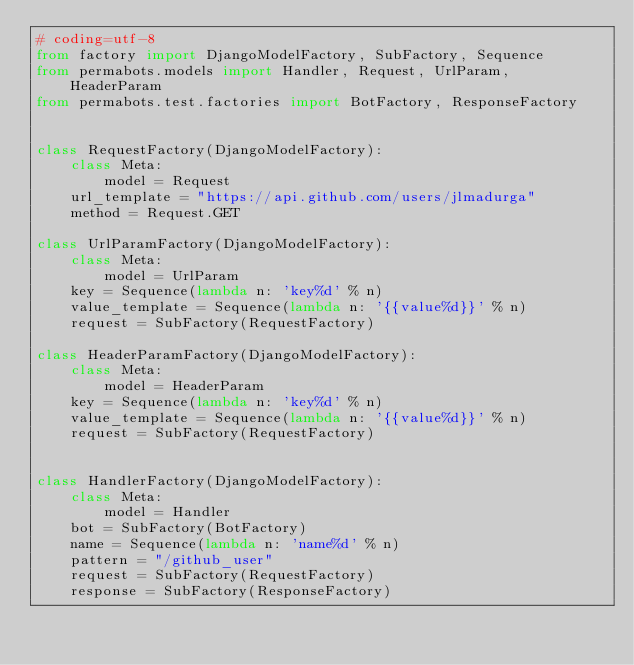<code> <loc_0><loc_0><loc_500><loc_500><_Python_># coding=utf-8
from factory import DjangoModelFactory, SubFactory, Sequence
from permabots.models import Handler, Request, UrlParam, HeaderParam
from permabots.test.factories import BotFactory, ResponseFactory


class RequestFactory(DjangoModelFactory):
    class Meta:
        model = Request
    url_template = "https://api.github.com/users/jlmadurga"
    method = Request.GET
    
class UrlParamFactory(DjangoModelFactory):
    class Meta:
        model = UrlParam
    key = Sequence(lambda n: 'key%d' % n)
    value_template = Sequence(lambda n: '{{value%d}}' % n)
    request = SubFactory(RequestFactory)
    
class HeaderParamFactory(DjangoModelFactory):
    class Meta:
        model = HeaderParam
    key = Sequence(lambda n: 'key%d' % n)
    value_template = Sequence(lambda n: '{{value%d}}' % n)
    request = SubFactory(RequestFactory)


class HandlerFactory(DjangoModelFactory):
    class Meta:
        model = Handler
    bot = SubFactory(BotFactory)
    name = Sequence(lambda n: 'name%d' % n)
    pattern = "/github_user" 
    request = SubFactory(RequestFactory)
    response = SubFactory(ResponseFactory)</code> 